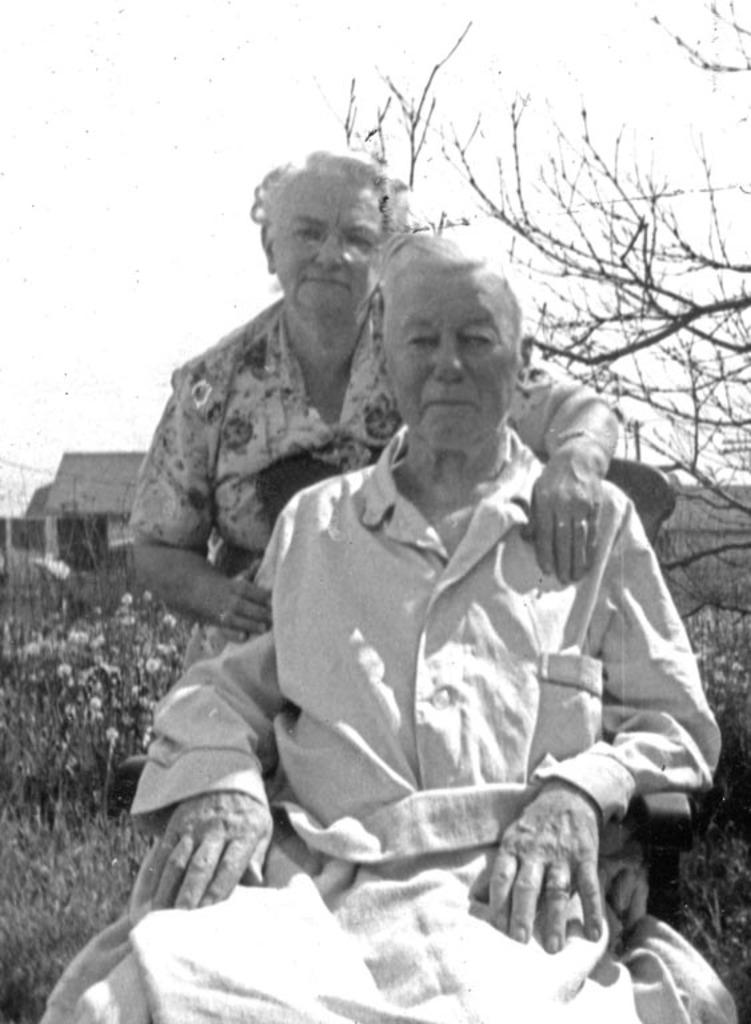What is the man in the image doing? The man is sitting in the image. What is the woman in the image doing? The woman is standing in the image. What can be seen in the background of the image? There are trees, plants, and the sky visible in the background of the image. What is the color scheme of the image? The image is black and white in color. What type of bun is the man holding in the image? There is no bun present in the image; it is a black and white image with a man sitting and a woman standing. 